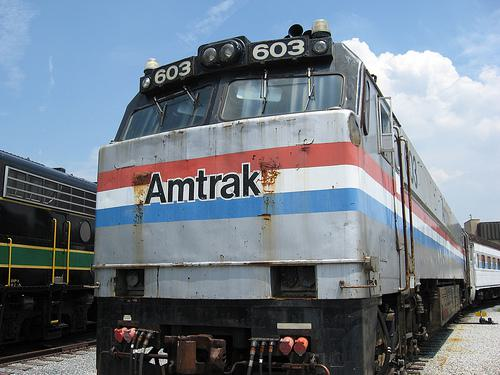How many unicorns are there in the image? While unicorns are fascinating mythical creatures often depicted in stories and artwork, there are no unicorns in this realistic image of an Amtrak train. 